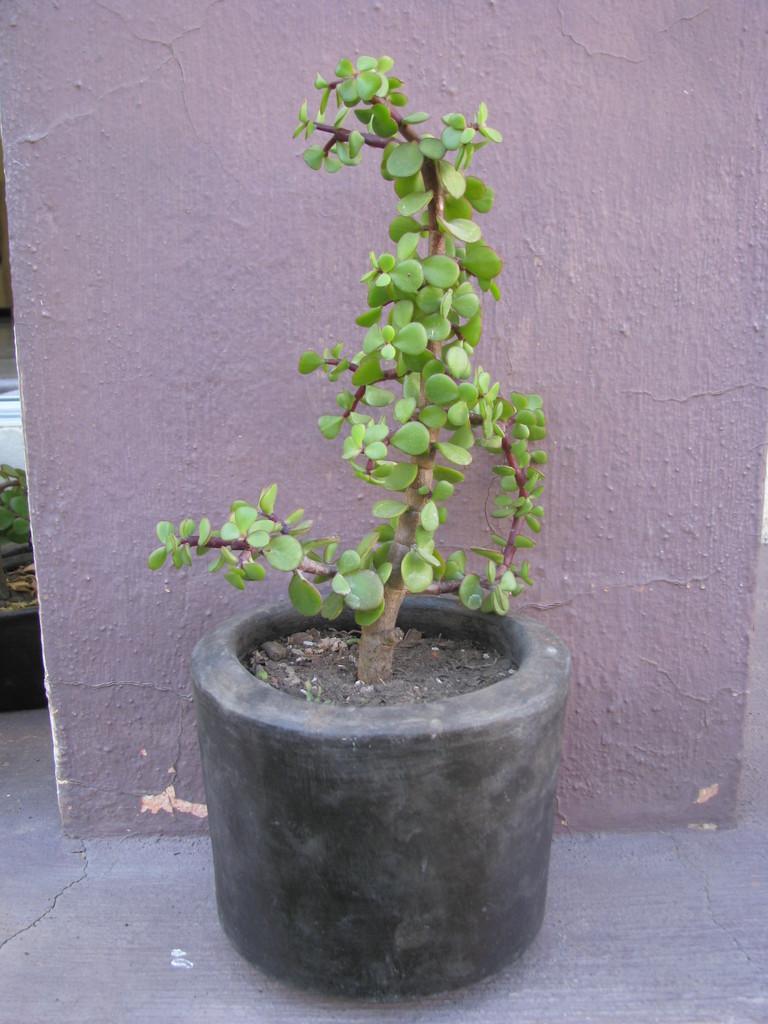How would you summarize this image in a sentence or two? In this image I can see a houseplant on the floor. In the background I can see a wall. This image is taken during a day outside the house. 